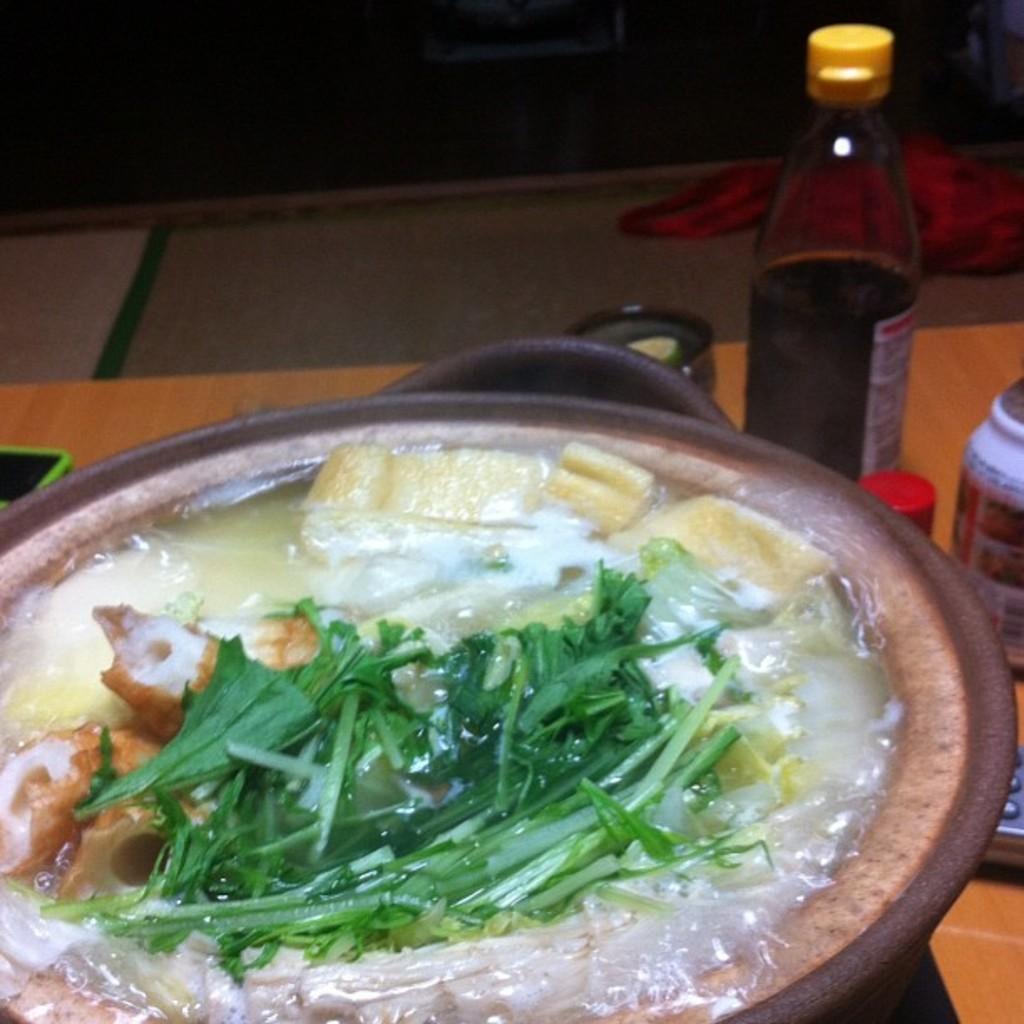Can you describe this image briefly? A recipe is prepared by using a vessel. The items are boiled in the water. There are some sauce bottle and other ingredients beside the vessel. 